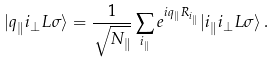Convert formula to latex. <formula><loc_0><loc_0><loc_500><loc_500>| { q } _ { \| } i _ { \perp } L \sigma \rangle = \frac { 1 } { \sqrt { N _ { \| } } } \sum _ { i _ { \| } } e ^ { i { q } _ { \| } { R } _ { i _ { \| } } } | i _ { \| } i _ { \perp } L \sigma \rangle \, .</formula> 